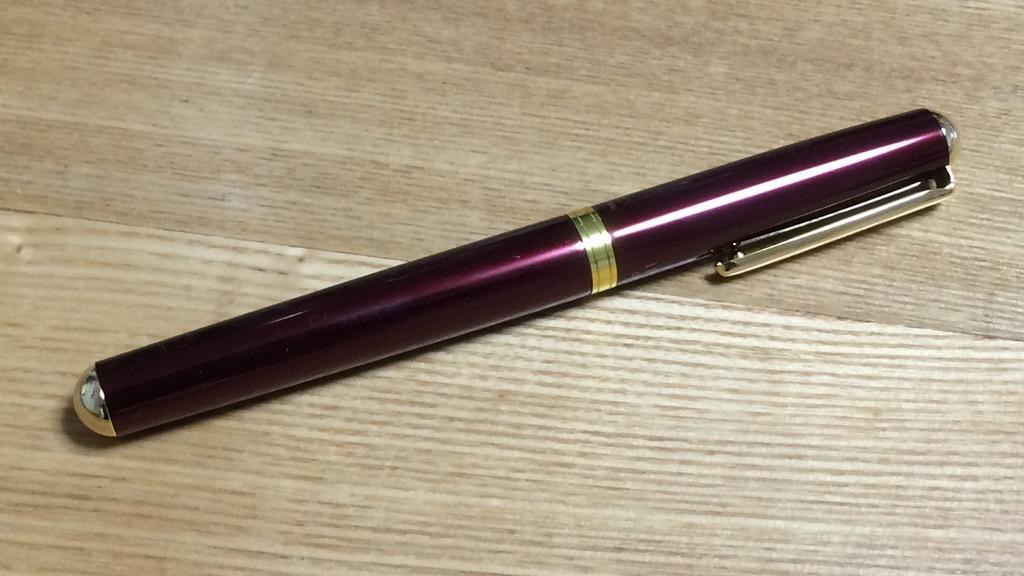Describe this image in one or two sentences. In this image we can see a pen on a wooden surface. 